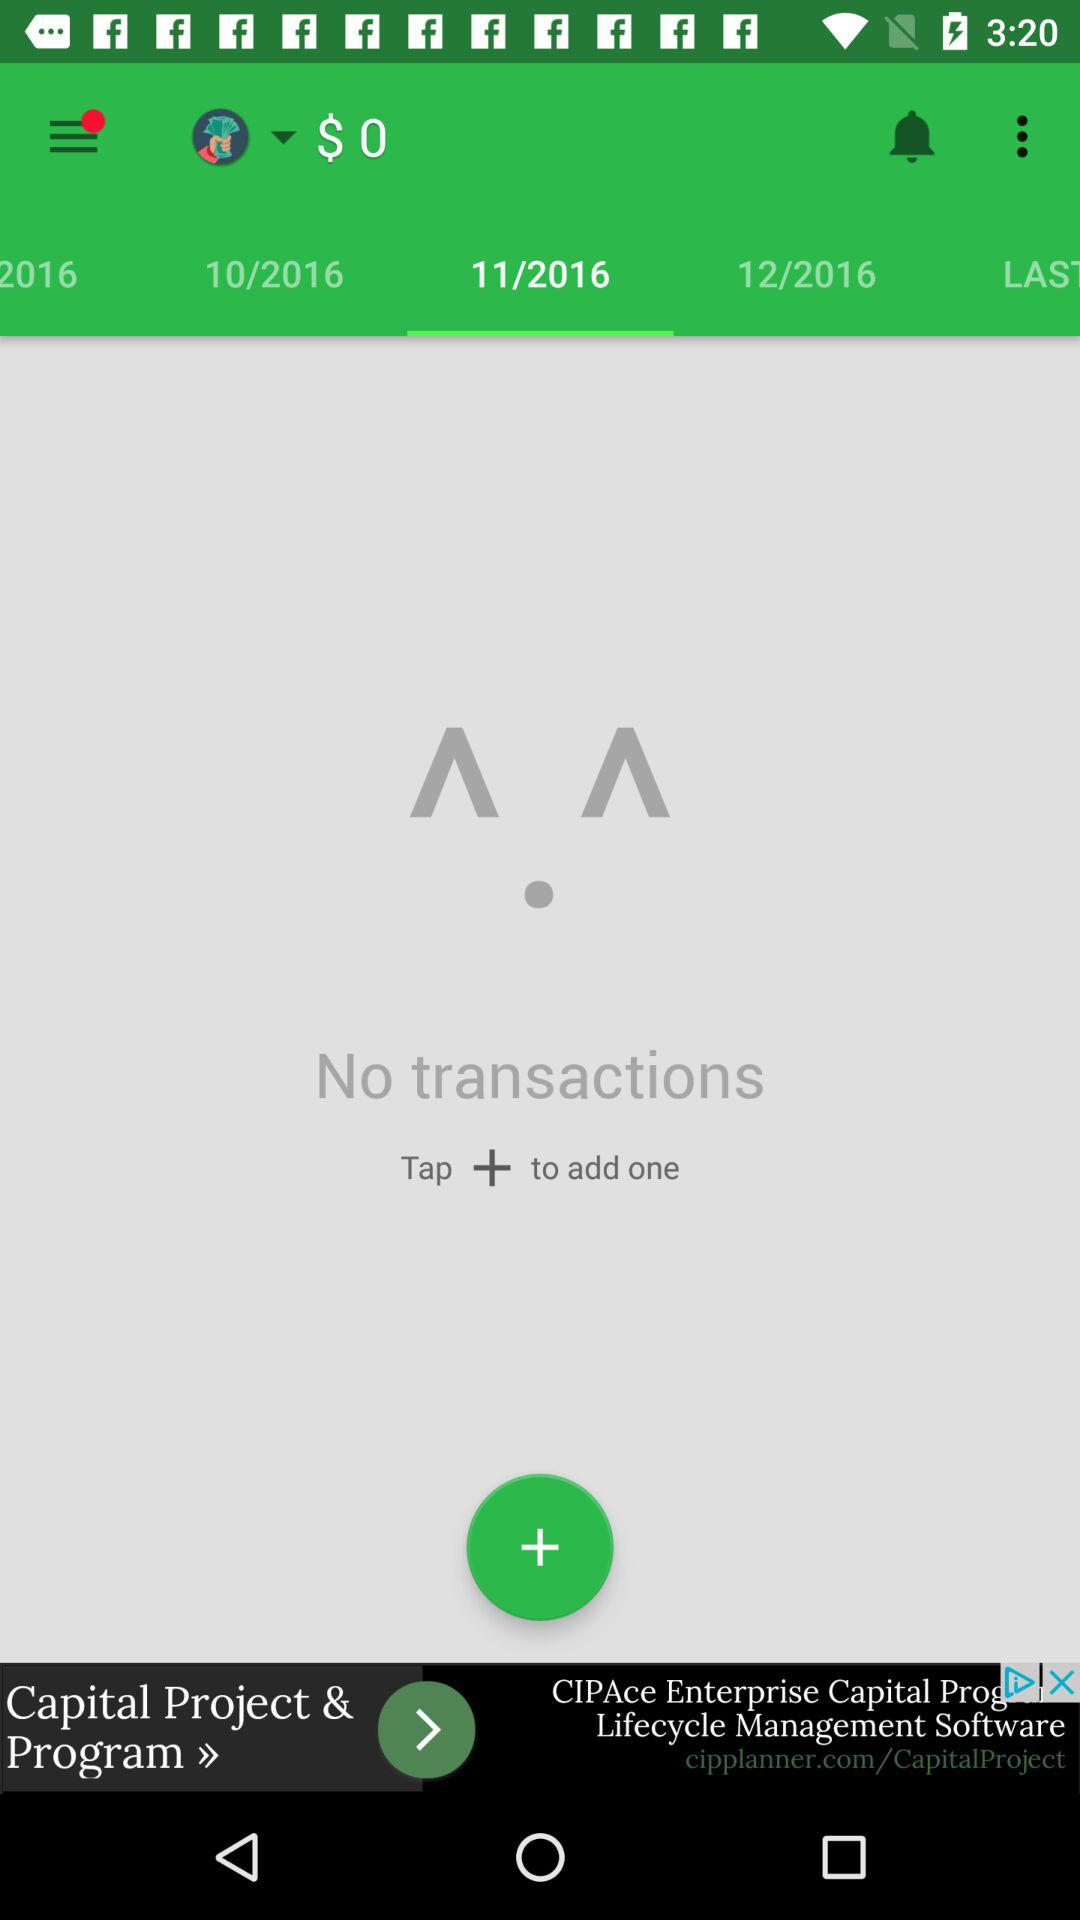How many transactions are displayed?
Answer the question using a single word or phrase. 0 